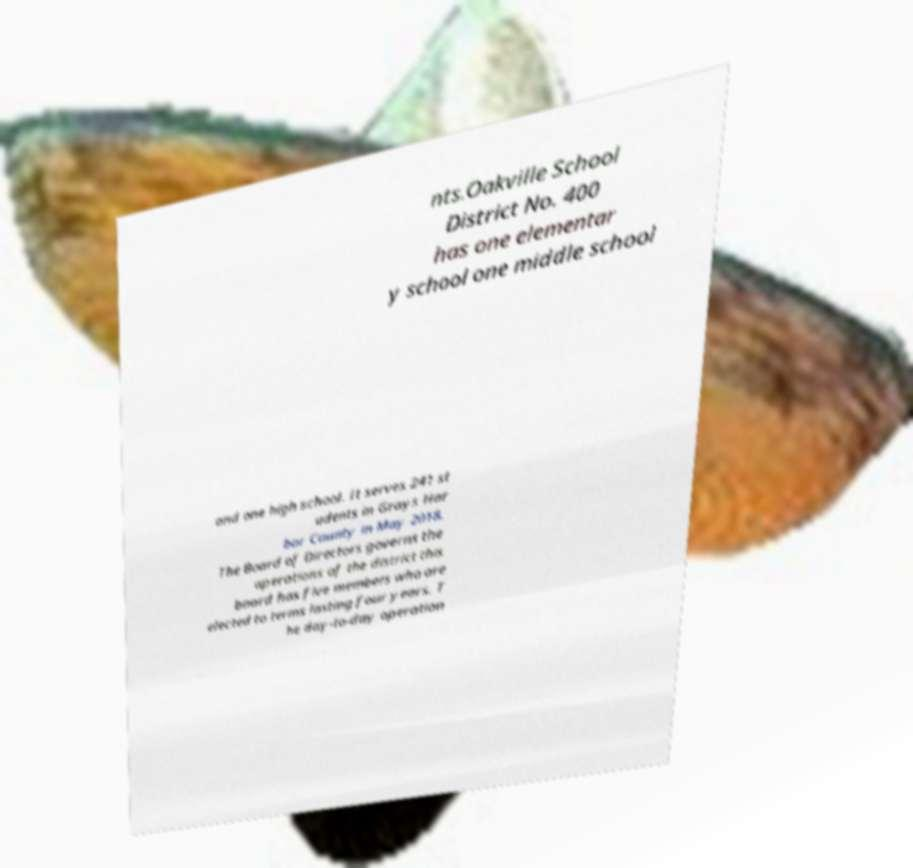Could you extract and type out the text from this image? nts.Oakville School District No. 400 has one elementar y school one middle school and one high school. It serves 241 st udents in Grays Har bor County in May 2018. The Board of Directors governs the operations of the district this board has five members who are elected to terms lasting four years. T he day-to-day operation 